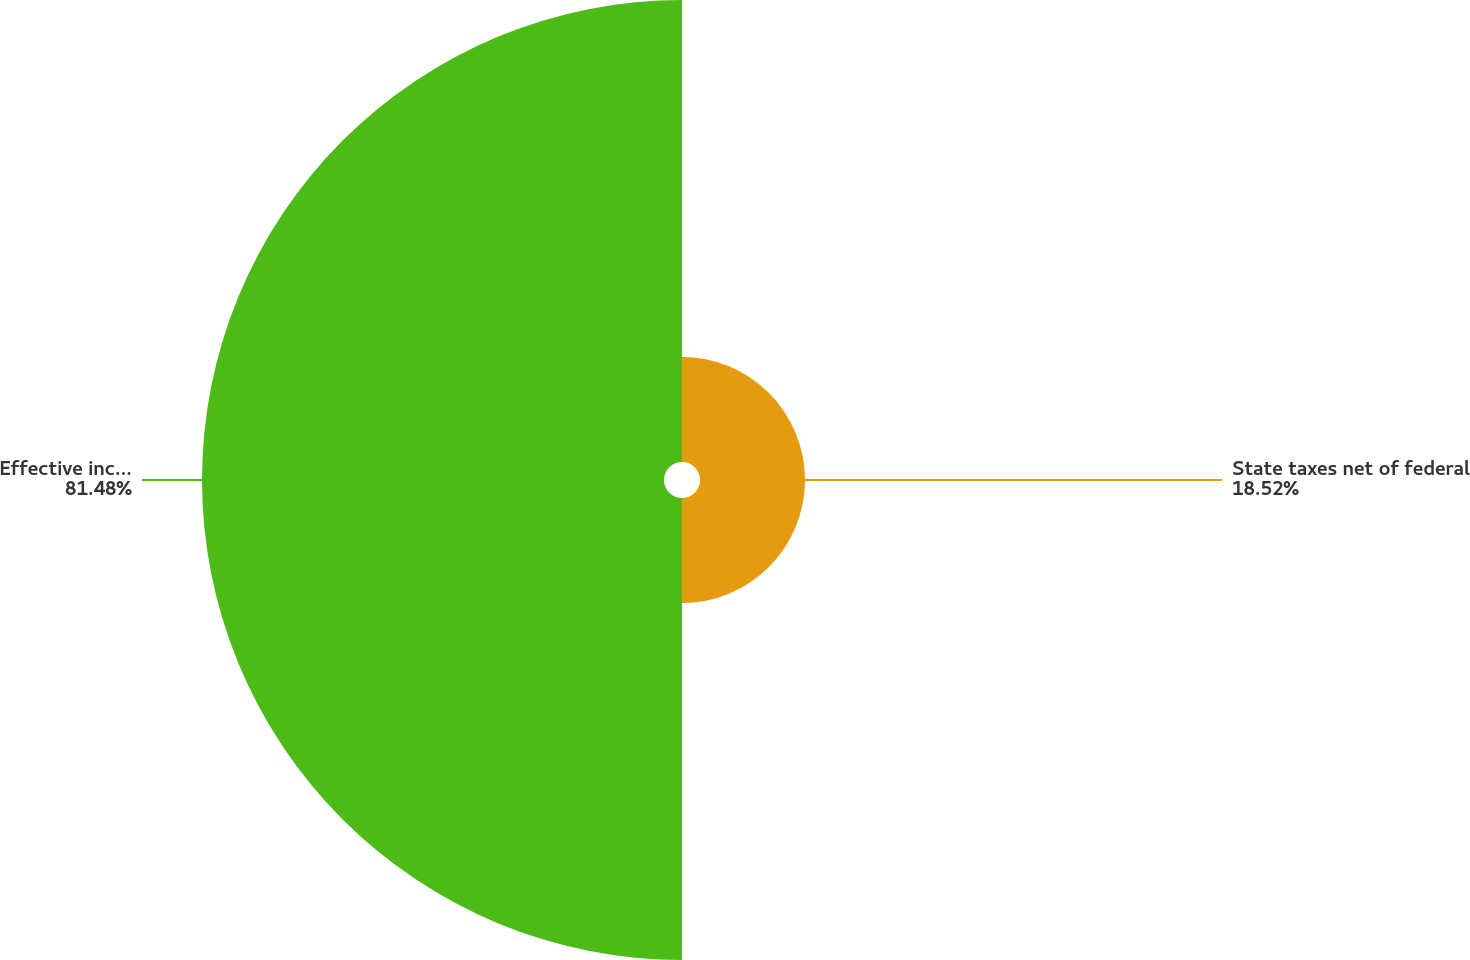<chart> <loc_0><loc_0><loc_500><loc_500><pie_chart><fcel>State taxes net of federal<fcel>Effective income tax rate<nl><fcel>18.52%<fcel>81.48%<nl></chart> 